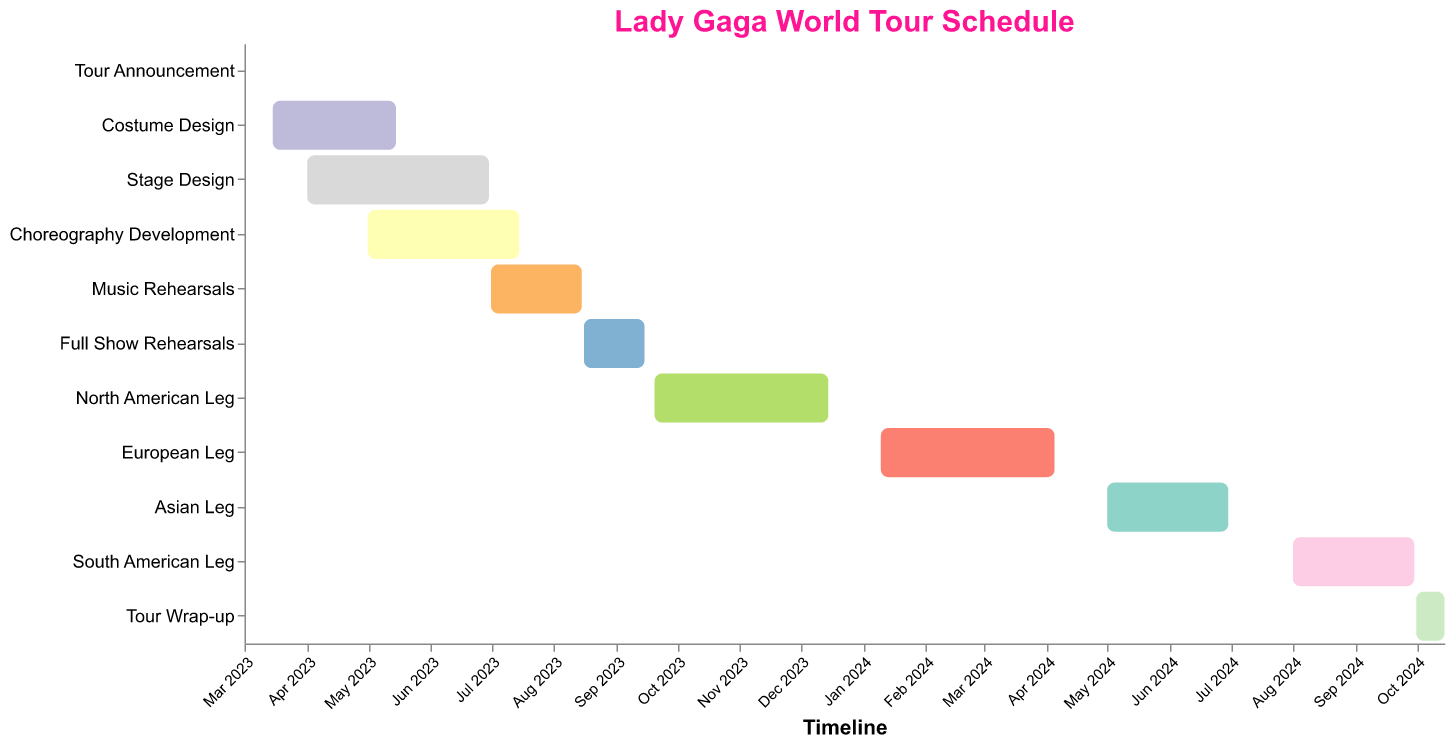What's the title of the figure? The title of a figure is usually prominent and located at the top of the chart. In this case, it states "Lady Gaga World Tour Schedule" clearly at the top of the Gantt Chart.
Answer: Lady Gaga World Tour Schedule What tasks overlap with "Stage Design"? To determine overlapping tasks, we need to look at the timeline of "Stage Design" (April 1, 2023 - June 30, 2023) and find tasks that fall within this range. "Costume Design" (March 15, 2023 - May 15, 2023) and "Choreography Development" (May 1, 2023 - July 15, 2023) overlap with "Stage Design".
Answer: Costume Design, Choreography Development How long does the "European Leg" of the tour last? Look at the start and end dates for "European Leg" (January 10, 2024 - April 5, 2024). Calculate the duration by subtracting the start date from the end date.
Answer: 86 days Which task has the shortest duration? To find the task with the shortest duration, calculate the duration of each task by subtracting the start date from the end date. The "Tour Announcement" runs only for one day (March 1, 2023).
Answer: Tour Announcement When does the "Full Show Rehearsals" start and end? Refer to the "Full Show Rehearsals" bar on the Gantt chart to get the temporal range. It starts on August 16, 2023, and ends on September 15, 2023.
Answer: August 16, 2023 - September 15, 2023 How many legs are there for the world tour, and which continents are included? By counting the number of distinct legs and identifying their geographic names on the chart, there are four legs: North American, European, Asian, and South American.
Answer: 4; North America, Europe, Asia, South America What is the combined duration of all the rehearsal periods including "Music Rehearsals" and "Full Show Rehearsals"? Combine the durations of "Music Rehearsals" and "Full Show Rehearsals". "Music Rehearsals" lasts 46 days (July 1, 2023 - August 15, 2023), and "Full Show Rehearsals" lasts 31 days (August 16, 2023 - September 15, 2023). So, 46 + 31 = 77 days.
Answer: 77 days Which task begins immediately after "Music Rehearsals" ends? Look for the next task on the timeline after "Music Rehearsals," which ends on August 15, 2023. "Full Show Rehearsals" begins immediately on August 16, 2023.
Answer: Full Show Rehearsals During which task does the transition between 2023 and 2024 occur? By checking the timeline, we can see that the "North American Leg" spans from September 20, 2023, to December 15, 2023. Then the "European Leg" starts on January 10, 2024. So, the transition may not occur within any task duration. Rather, "European Leg" follows the "North American Leg" after a brief break.
Answer: No task transitions Is there any gap between the "Asian Leg" and the "South American Leg"? Observe the end date of "Asian Leg" (June 30, 2024) and the start date of "South American Leg" (August 1, 2024). The gap is the period between these two dates.
Answer: 31 days 